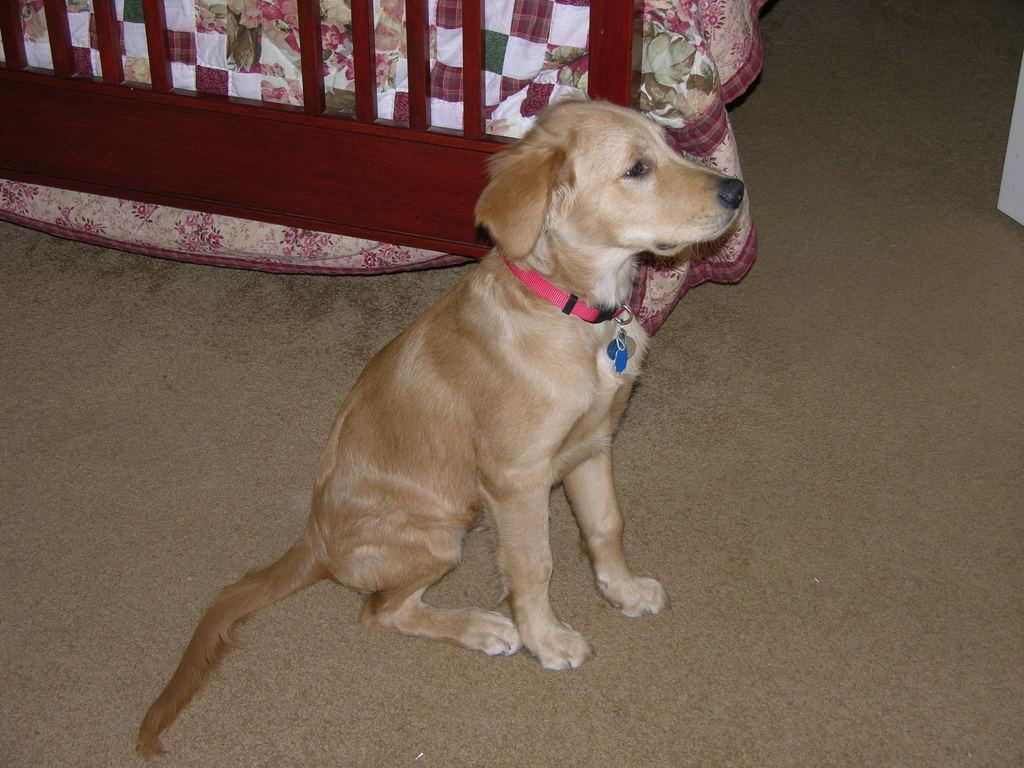What is the main subject in the center of the image? There is a dog in the center of the image. What can be seen in the background of the image? There is a bed in the background of the image. What is on the bed? There is a blanket on the bed. What type of hands can be seen holding the dog in the image? There are no hands visible in the image; the dog is not being held by anyone. 